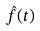Convert formula to latex. <formula><loc_0><loc_0><loc_500><loc_500>\hat { f } ( t )</formula> 